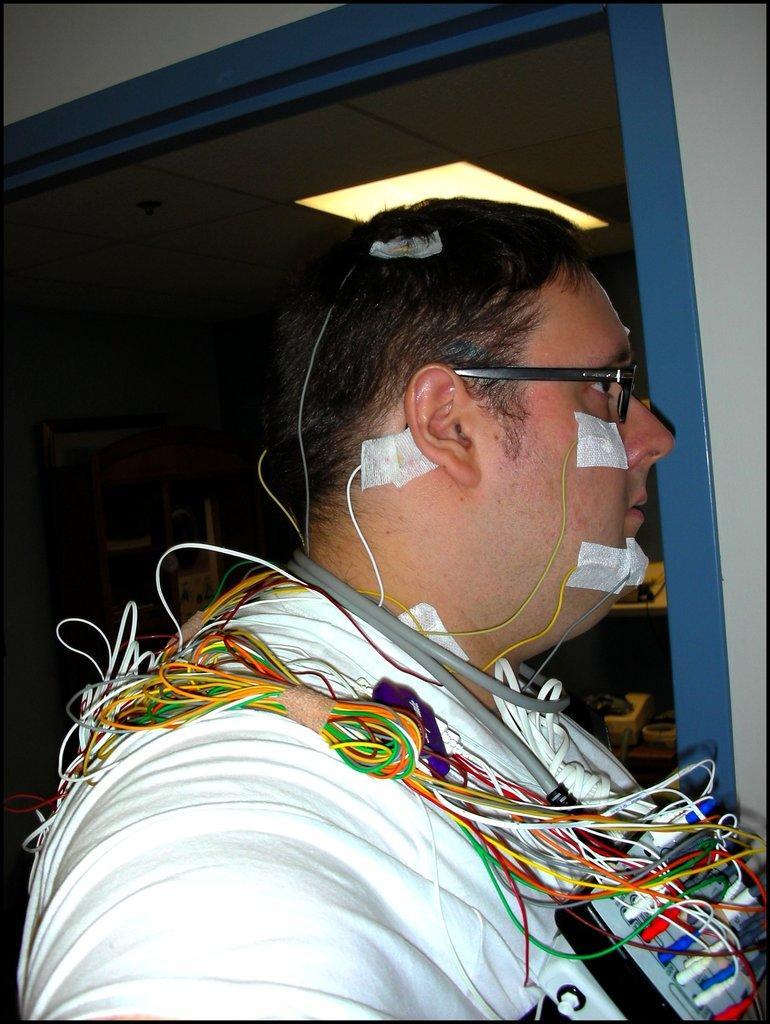Please provide a concise description of this image. This image is taken indoors. In the background there is a wall. There are a few things on the shelves. In the middle of the image there is a man and there are many wires on him. There is a ceiling with a light. 